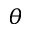Convert formula to latex. <formula><loc_0><loc_0><loc_500><loc_500>\theta</formula> 